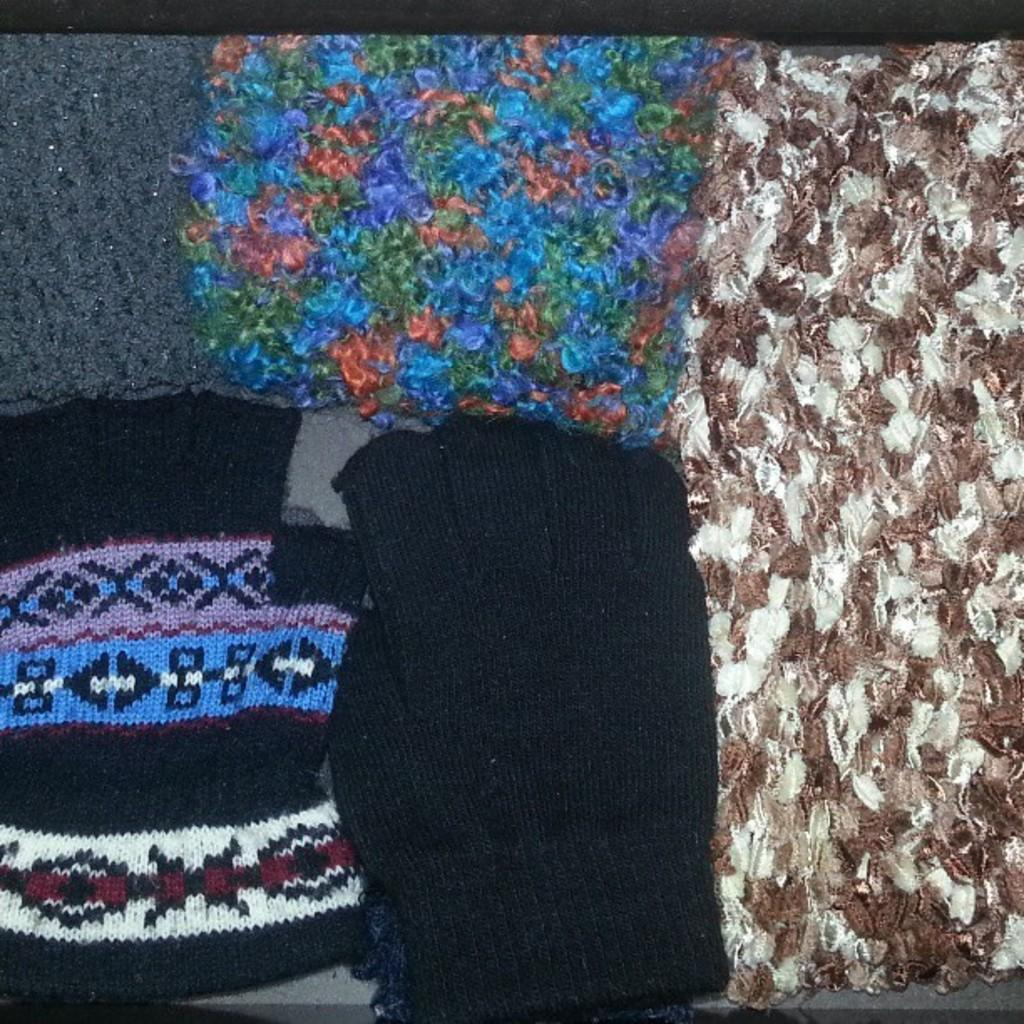What type of clothes are visible in the image? There are woolen clothes in the image. What hobbies do the woolen clothes have in the image? Woolen clothes do not have hobbies, as they are inanimate objects. 